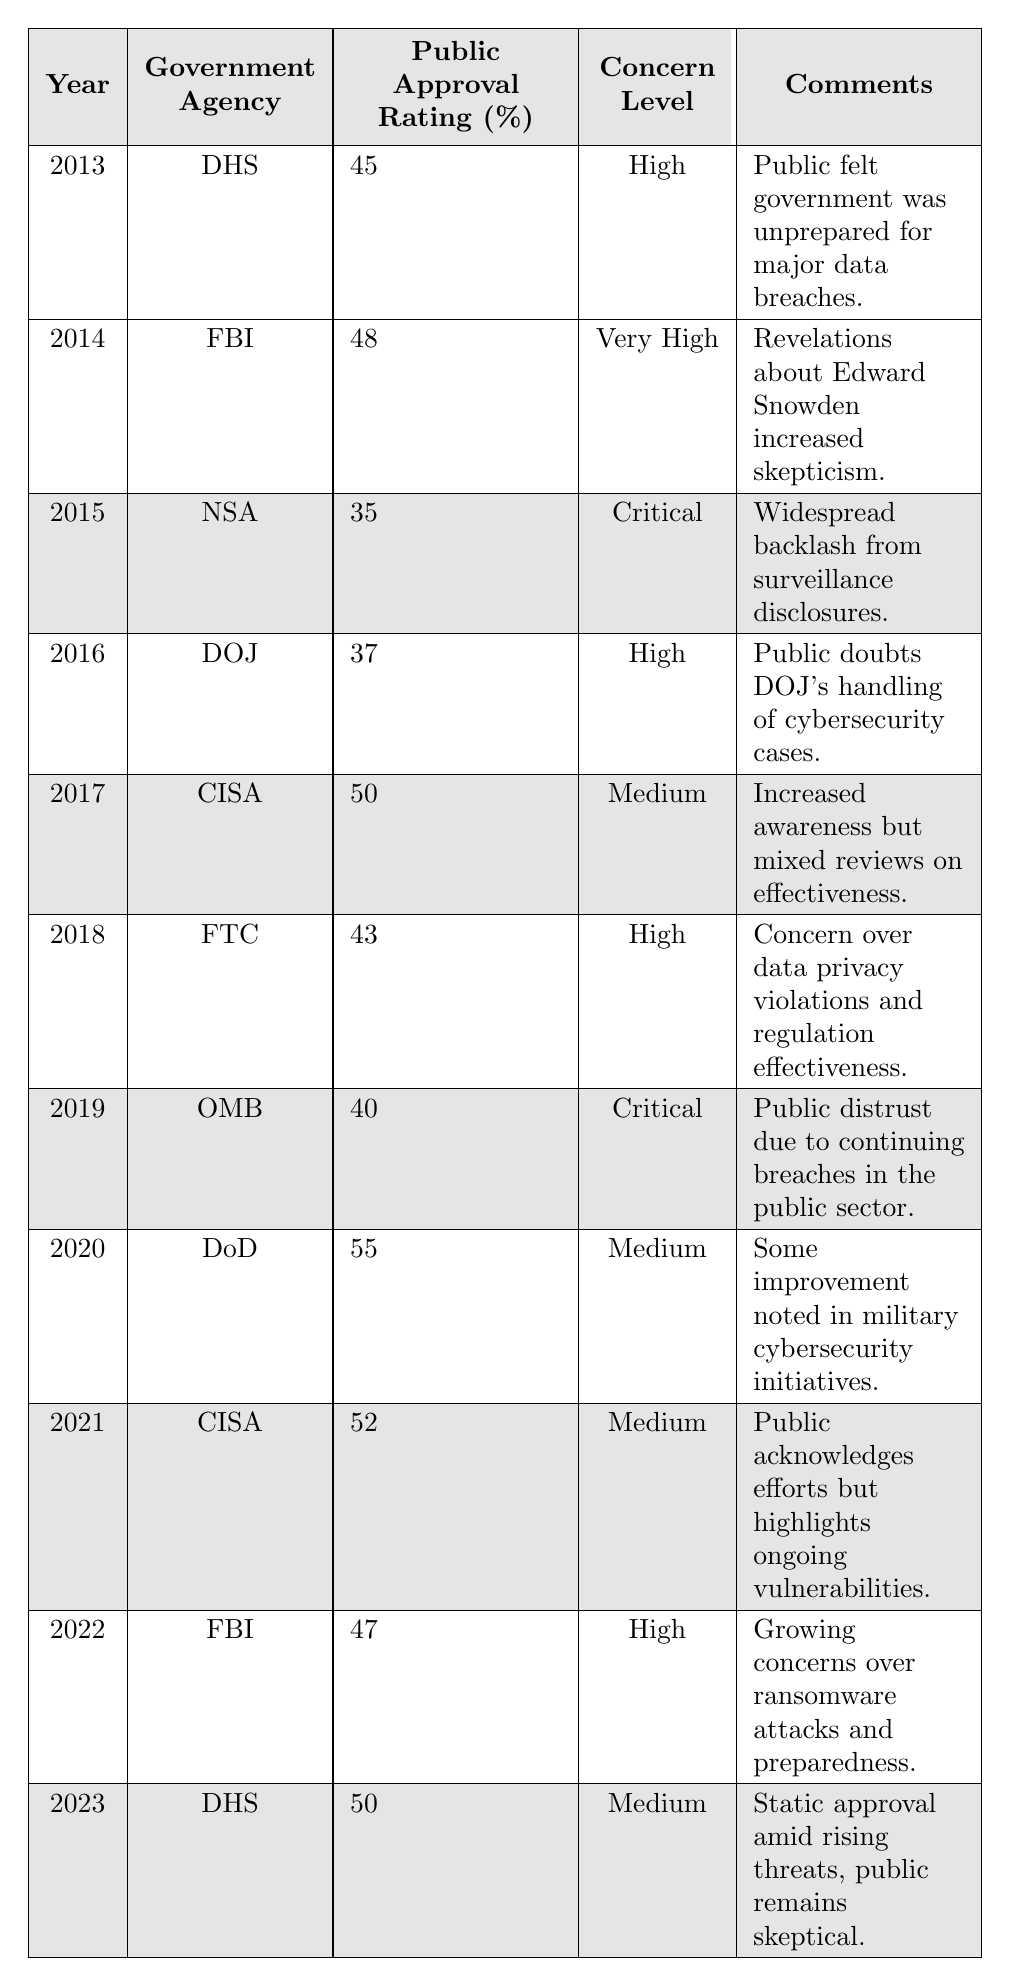What was the public approval rating for the Federal Bureau of Investigation (FBI) in 2022? The table shows that in 2022, the FBI had a public approval rating of 47%.
Answer: 47% Which government agency had the highest public approval rating in the table? The Department of Defense (DoD) had the highest public approval rating at 55% in 2020.
Answer: Department of Defense (DoD) What year saw the lowest public approval rating and what was it? The lowest public approval rating was 35% for the National Security Agency (NSA) in 2015.
Answer: 2015, 35% How many years had a public approval rating below 40%? Based on the table, there were three years (2015, 2016, and 2019) with approval ratings below 40%, specifically: 35% (NSA, 2015), 37% (DOJ, 2016), and 40% (OMB, 2019).
Answer: 3 In which years did the Cybersecurity & Infrastructure Security Agency (CISA) appear, and what were their approval ratings? CISA appeared in 2017 with a rating of 50% and in 2021 with a rating of 52%.
Answer: 2017 (50%), 2021 (52%) What is the average public approval rating from 2013 to 2023? The sum of the approval ratings over these years is 45 + 48 + 35 + 37 + 50 + 43 + 40 + 55 + 52 + 47 + 50 =  457. There are 11 data points, so the average is 457/11 = 41.55.
Answer: 41.55 Did the public approval rating for the Department of Homeland Security (DHS) improve from 2013 to 2023? In 2013, DHS had an approval rating of 45%, and in 2023, it had an approval rating of 50%. This indicates an improvement of 5 percentage points.
Answer: Yes What concern level was associated with the public approval rating of the National Security Agency (NSA) in 2015? The concern level associated with the NSA in 2015 was "Critical."
Answer: Critical Which agency experienced a public approval rating increase from 2020 to 2021? The Cybersecurity & Infrastructure Security Agency (CISA) increased its approval rating from 50% in 2017 to 52% in 2021.
Answer: CISA What trend can be observed regarding the public approval rating and concern level over the decade? Generally, as the public approval rating remains static or declines, the concern level fluctuates but tends to stay high or critical, showing persistent public skepticism towards government agencies handling cybersecurity threats.
Answer: Public skepticism persists In what year did the Federal Trade Commission (FTC) receive a public approval rating below 45%? The FTC received a rating of 43% in 2018, which is below 45%.
Answer: 2018 